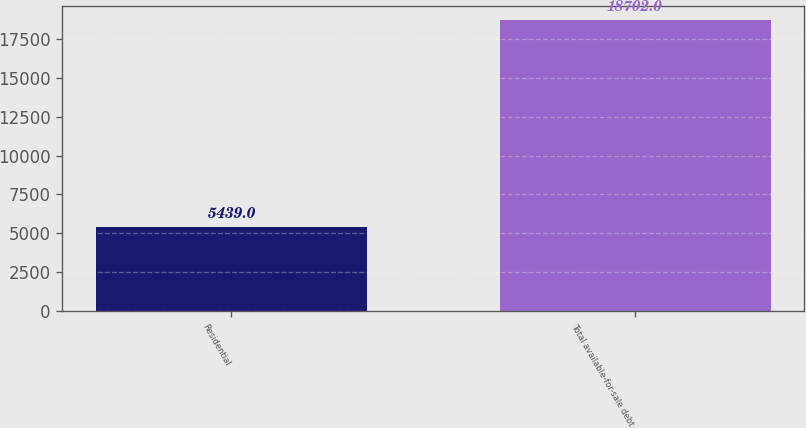<chart> <loc_0><loc_0><loc_500><loc_500><bar_chart><fcel>Residential<fcel>Total available-for-sale debt<nl><fcel>5439<fcel>18702<nl></chart> 